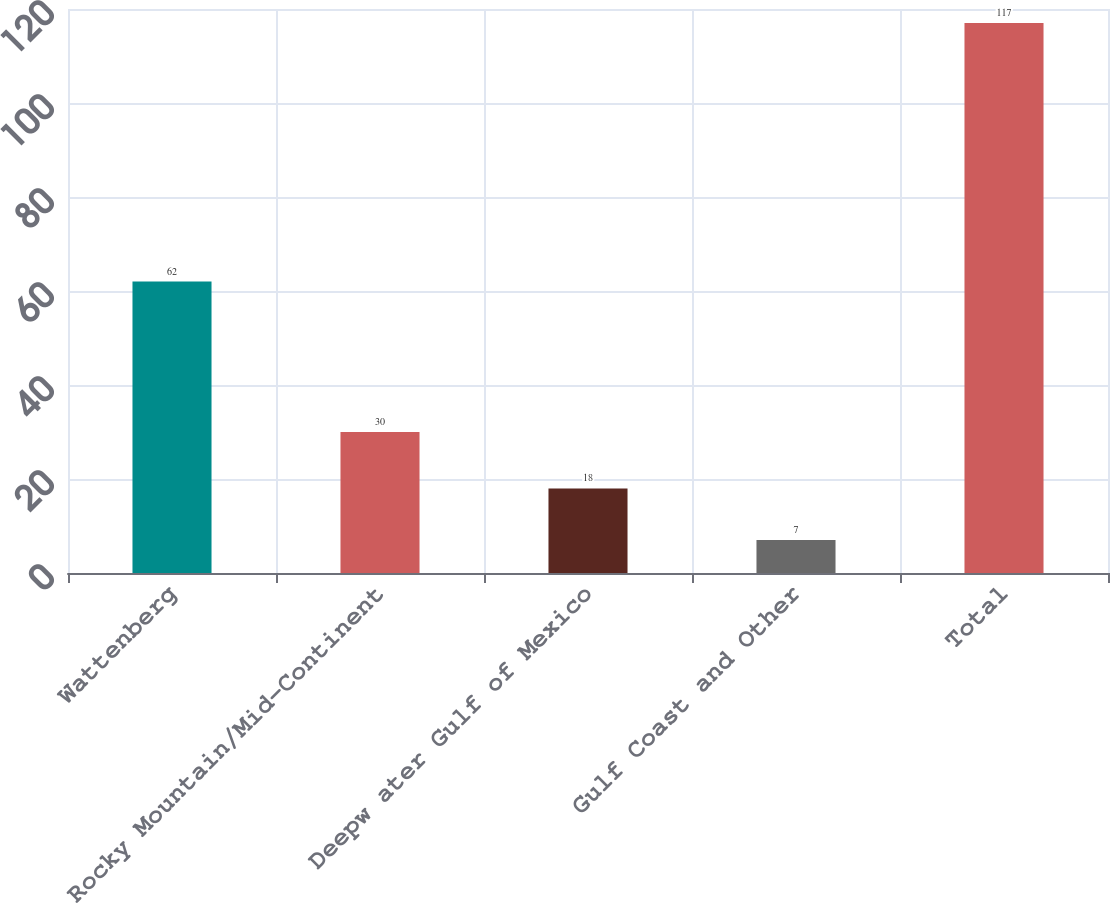Convert chart to OTSL. <chart><loc_0><loc_0><loc_500><loc_500><bar_chart><fcel>Wattenberg<fcel>Rocky Mountain/Mid-Continent<fcel>Deepw ater Gulf of Mexico<fcel>Gulf Coast and Other<fcel>Total<nl><fcel>62<fcel>30<fcel>18<fcel>7<fcel>117<nl></chart> 